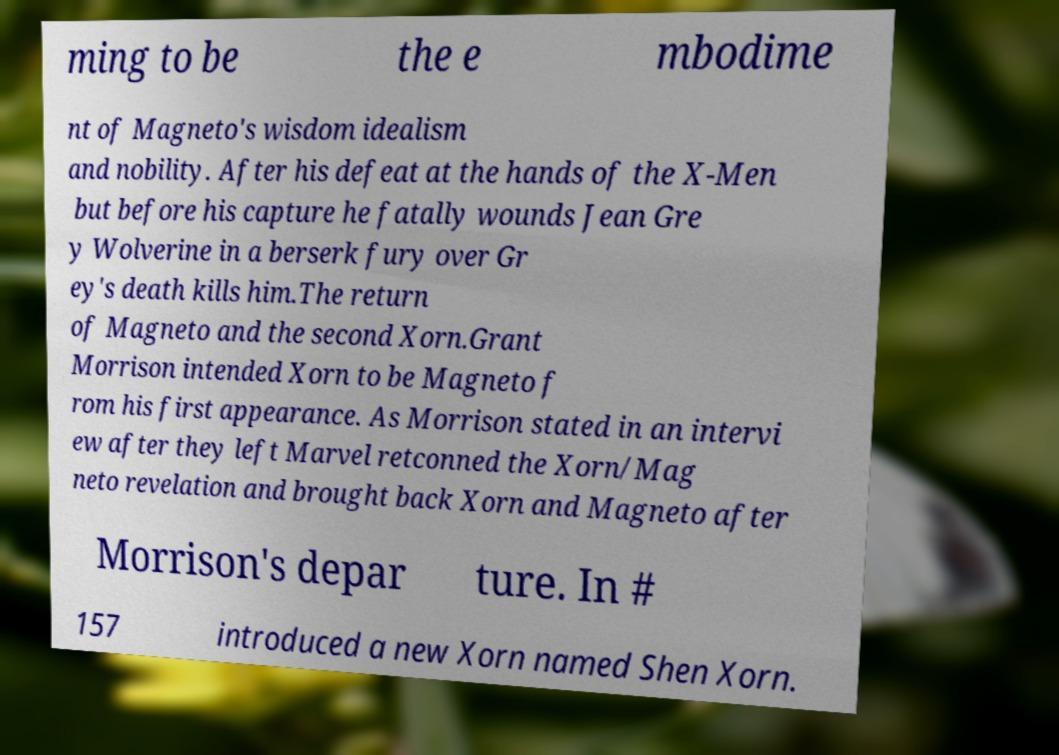Could you extract and type out the text from this image? ming to be the e mbodime nt of Magneto's wisdom idealism and nobility. After his defeat at the hands of the X-Men but before his capture he fatally wounds Jean Gre y Wolverine in a berserk fury over Gr ey's death kills him.The return of Magneto and the second Xorn.Grant Morrison intended Xorn to be Magneto f rom his first appearance. As Morrison stated in an intervi ew after they left Marvel retconned the Xorn/Mag neto revelation and brought back Xorn and Magneto after Morrison's depar ture. In # 157 introduced a new Xorn named Shen Xorn. 